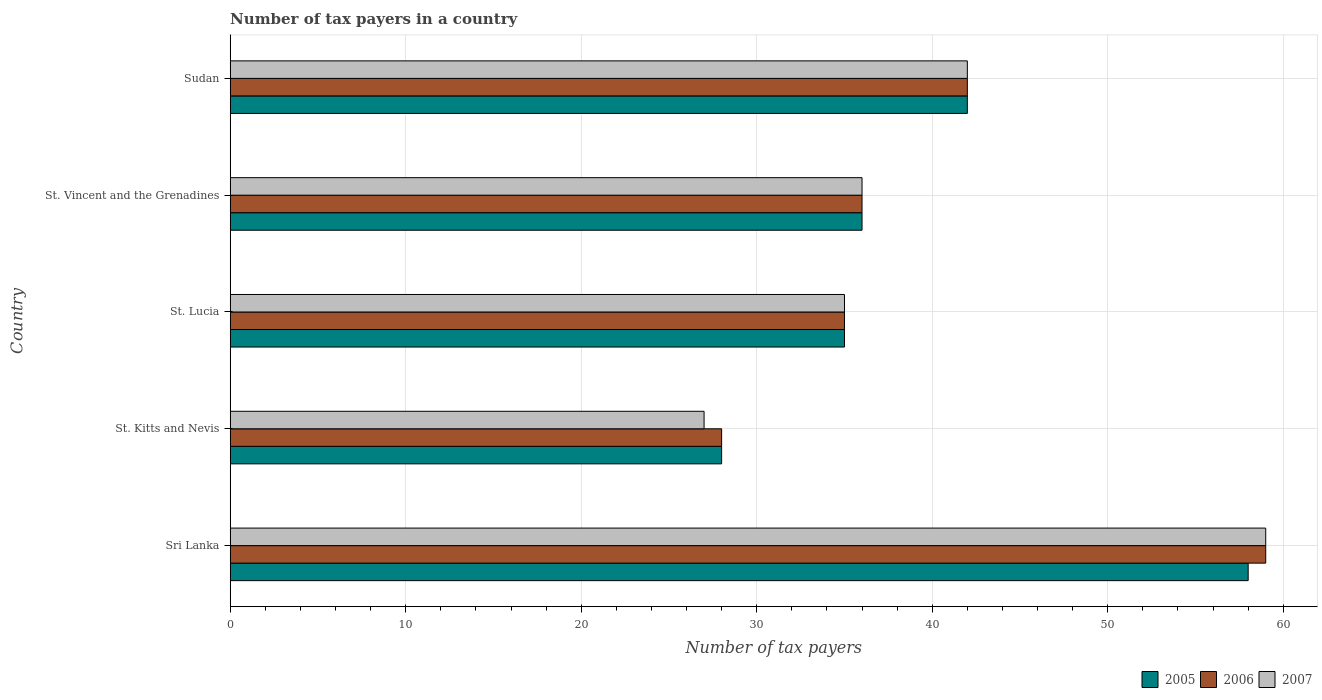How many different coloured bars are there?
Your answer should be very brief. 3. How many groups of bars are there?
Ensure brevity in your answer.  5. Are the number of bars per tick equal to the number of legend labels?
Offer a terse response. Yes. Are the number of bars on each tick of the Y-axis equal?
Offer a very short reply. Yes. How many bars are there on the 4th tick from the top?
Provide a succinct answer. 3. How many bars are there on the 3rd tick from the bottom?
Your answer should be very brief. 3. What is the label of the 1st group of bars from the top?
Your response must be concise. Sudan. In how many cases, is the number of bars for a given country not equal to the number of legend labels?
Your answer should be compact. 0. What is the number of tax payers in in 2006 in St. Lucia?
Make the answer very short. 35. Across all countries, what is the maximum number of tax payers in in 2005?
Make the answer very short. 58. Across all countries, what is the minimum number of tax payers in in 2006?
Keep it short and to the point. 28. In which country was the number of tax payers in in 2005 maximum?
Provide a short and direct response. Sri Lanka. In which country was the number of tax payers in in 2005 minimum?
Ensure brevity in your answer.  St. Kitts and Nevis. What is the total number of tax payers in in 2006 in the graph?
Your response must be concise. 200. What is the difference between the number of tax payers in in 2007 in St. Vincent and the Grenadines and that in Sudan?
Make the answer very short. -6. In how many countries, is the number of tax payers in in 2006 greater than 56 ?
Ensure brevity in your answer.  1. What is the ratio of the number of tax payers in in 2006 in Sri Lanka to that in St. Vincent and the Grenadines?
Make the answer very short. 1.64. What is the difference between the highest and the second highest number of tax payers in in 2005?
Keep it short and to the point. 16. What is the difference between the highest and the lowest number of tax payers in in 2007?
Your answer should be very brief. 32. In how many countries, is the number of tax payers in in 2005 greater than the average number of tax payers in in 2005 taken over all countries?
Offer a very short reply. 2. Is the sum of the number of tax payers in in 2006 in St. Vincent and the Grenadines and Sudan greater than the maximum number of tax payers in in 2005 across all countries?
Your response must be concise. Yes. How many bars are there?
Offer a terse response. 15. Are all the bars in the graph horizontal?
Provide a short and direct response. Yes. What is the difference between two consecutive major ticks on the X-axis?
Keep it short and to the point. 10. Are the values on the major ticks of X-axis written in scientific E-notation?
Offer a very short reply. No. Does the graph contain grids?
Your response must be concise. Yes. How are the legend labels stacked?
Give a very brief answer. Horizontal. What is the title of the graph?
Your response must be concise. Number of tax payers in a country. Does "1985" appear as one of the legend labels in the graph?
Your answer should be compact. No. What is the label or title of the X-axis?
Give a very brief answer. Number of tax payers. What is the label or title of the Y-axis?
Give a very brief answer. Country. What is the Number of tax payers in 2005 in Sri Lanka?
Your answer should be compact. 58. What is the Number of tax payers of 2006 in Sri Lanka?
Your answer should be compact. 59. What is the Number of tax payers in 2006 in St. Lucia?
Your response must be concise. 35. What is the Number of tax payers of 2007 in St. Lucia?
Offer a very short reply. 35. What is the Number of tax payers in 2006 in St. Vincent and the Grenadines?
Offer a terse response. 36. Across all countries, what is the maximum Number of tax payers in 2005?
Make the answer very short. 58. Across all countries, what is the maximum Number of tax payers in 2007?
Give a very brief answer. 59. Across all countries, what is the minimum Number of tax payers in 2005?
Your answer should be compact. 28. Across all countries, what is the minimum Number of tax payers of 2006?
Offer a very short reply. 28. What is the total Number of tax payers of 2005 in the graph?
Ensure brevity in your answer.  199. What is the total Number of tax payers of 2006 in the graph?
Keep it short and to the point. 200. What is the total Number of tax payers in 2007 in the graph?
Offer a terse response. 199. What is the difference between the Number of tax payers of 2005 in Sri Lanka and that in St. Kitts and Nevis?
Give a very brief answer. 30. What is the difference between the Number of tax payers in 2005 in Sri Lanka and that in St. Lucia?
Your answer should be compact. 23. What is the difference between the Number of tax payers of 2007 in Sri Lanka and that in St. Lucia?
Your answer should be compact. 24. What is the difference between the Number of tax payers in 2005 in Sri Lanka and that in St. Vincent and the Grenadines?
Ensure brevity in your answer.  22. What is the difference between the Number of tax payers of 2006 in Sri Lanka and that in St. Vincent and the Grenadines?
Offer a very short reply. 23. What is the difference between the Number of tax payers of 2007 in Sri Lanka and that in St. Vincent and the Grenadines?
Your answer should be very brief. 23. What is the difference between the Number of tax payers of 2005 in Sri Lanka and that in Sudan?
Provide a short and direct response. 16. What is the difference between the Number of tax payers in 2007 in Sri Lanka and that in Sudan?
Provide a short and direct response. 17. What is the difference between the Number of tax payers in 2005 in St. Kitts and Nevis and that in St. Lucia?
Give a very brief answer. -7. What is the difference between the Number of tax payers of 2006 in St. Kitts and Nevis and that in St. Lucia?
Provide a short and direct response. -7. What is the difference between the Number of tax payers of 2007 in St. Kitts and Nevis and that in St. Lucia?
Your response must be concise. -8. What is the difference between the Number of tax payers of 2005 in St. Kitts and Nevis and that in St. Vincent and the Grenadines?
Provide a succinct answer. -8. What is the difference between the Number of tax payers in 2006 in St. Kitts and Nevis and that in Sudan?
Your response must be concise. -14. What is the difference between the Number of tax payers of 2005 in St. Lucia and that in St. Vincent and the Grenadines?
Ensure brevity in your answer.  -1. What is the difference between the Number of tax payers in 2006 in St. Lucia and that in Sudan?
Your answer should be very brief. -7. What is the difference between the Number of tax payers of 2007 in St. Lucia and that in Sudan?
Offer a very short reply. -7. What is the difference between the Number of tax payers of 2005 in St. Vincent and the Grenadines and that in Sudan?
Your answer should be compact. -6. What is the difference between the Number of tax payers of 2005 in Sri Lanka and the Number of tax payers of 2007 in St. Kitts and Nevis?
Provide a short and direct response. 31. What is the difference between the Number of tax payers in 2006 in Sri Lanka and the Number of tax payers in 2007 in St. Lucia?
Provide a short and direct response. 24. What is the difference between the Number of tax payers in 2005 in Sri Lanka and the Number of tax payers in 2006 in St. Vincent and the Grenadines?
Give a very brief answer. 22. What is the difference between the Number of tax payers in 2005 in Sri Lanka and the Number of tax payers in 2007 in St. Vincent and the Grenadines?
Your answer should be compact. 22. What is the difference between the Number of tax payers in 2005 in Sri Lanka and the Number of tax payers in 2006 in Sudan?
Your response must be concise. 16. What is the difference between the Number of tax payers in 2005 in St. Kitts and Nevis and the Number of tax payers in 2006 in St. Vincent and the Grenadines?
Offer a terse response. -8. What is the difference between the Number of tax payers in 2005 in St. Kitts and Nevis and the Number of tax payers in 2007 in St. Vincent and the Grenadines?
Make the answer very short. -8. What is the difference between the Number of tax payers of 2005 in St. Kitts and Nevis and the Number of tax payers of 2006 in Sudan?
Your answer should be compact. -14. What is the difference between the Number of tax payers in 2005 in St. Lucia and the Number of tax payers in 2006 in St. Vincent and the Grenadines?
Your answer should be compact. -1. What is the difference between the Number of tax payers in 2006 in St. Lucia and the Number of tax payers in 2007 in St. Vincent and the Grenadines?
Provide a succinct answer. -1. What is the difference between the Number of tax payers in 2006 in St. Lucia and the Number of tax payers in 2007 in Sudan?
Keep it short and to the point. -7. What is the difference between the Number of tax payers in 2005 in St. Vincent and the Grenadines and the Number of tax payers in 2006 in Sudan?
Offer a very short reply. -6. What is the difference between the Number of tax payers of 2005 in St. Vincent and the Grenadines and the Number of tax payers of 2007 in Sudan?
Your answer should be very brief. -6. What is the average Number of tax payers of 2005 per country?
Provide a succinct answer. 39.8. What is the average Number of tax payers in 2007 per country?
Your answer should be very brief. 39.8. What is the difference between the Number of tax payers in 2005 and Number of tax payers in 2006 in Sri Lanka?
Offer a terse response. -1. What is the difference between the Number of tax payers in 2005 and Number of tax payers in 2007 in Sri Lanka?
Make the answer very short. -1. What is the difference between the Number of tax payers of 2006 and Number of tax payers of 2007 in Sri Lanka?
Your response must be concise. 0. What is the difference between the Number of tax payers in 2005 and Number of tax payers in 2006 in St. Vincent and the Grenadines?
Give a very brief answer. 0. What is the difference between the Number of tax payers in 2005 and Number of tax payers in 2006 in Sudan?
Offer a very short reply. 0. What is the ratio of the Number of tax payers in 2005 in Sri Lanka to that in St. Kitts and Nevis?
Provide a short and direct response. 2.07. What is the ratio of the Number of tax payers in 2006 in Sri Lanka to that in St. Kitts and Nevis?
Your answer should be very brief. 2.11. What is the ratio of the Number of tax payers in 2007 in Sri Lanka to that in St. Kitts and Nevis?
Offer a terse response. 2.19. What is the ratio of the Number of tax payers in 2005 in Sri Lanka to that in St. Lucia?
Ensure brevity in your answer.  1.66. What is the ratio of the Number of tax payers in 2006 in Sri Lanka to that in St. Lucia?
Your answer should be compact. 1.69. What is the ratio of the Number of tax payers of 2007 in Sri Lanka to that in St. Lucia?
Your response must be concise. 1.69. What is the ratio of the Number of tax payers of 2005 in Sri Lanka to that in St. Vincent and the Grenadines?
Offer a terse response. 1.61. What is the ratio of the Number of tax payers in 2006 in Sri Lanka to that in St. Vincent and the Grenadines?
Provide a short and direct response. 1.64. What is the ratio of the Number of tax payers of 2007 in Sri Lanka to that in St. Vincent and the Grenadines?
Your response must be concise. 1.64. What is the ratio of the Number of tax payers in 2005 in Sri Lanka to that in Sudan?
Ensure brevity in your answer.  1.38. What is the ratio of the Number of tax payers in 2006 in Sri Lanka to that in Sudan?
Offer a terse response. 1.4. What is the ratio of the Number of tax payers in 2007 in Sri Lanka to that in Sudan?
Give a very brief answer. 1.4. What is the ratio of the Number of tax payers of 2005 in St. Kitts and Nevis to that in St. Lucia?
Offer a terse response. 0.8. What is the ratio of the Number of tax payers of 2007 in St. Kitts and Nevis to that in St. Lucia?
Make the answer very short. 0.77. What is the ratio of the Number of tax payers of 2007 in St. Kitts and Nevis to that in St. Vincent and the Grenadines?
Offer a terse response. 0.75. What is the ratio of the Number of tax payers in 2005 in St. Kitts and Nevis to that in Sudan?
Give a very brief answer. 0.67. What is the ratio of the Number of tax payers in 2006 in St. Kitts and Nevis to that in Sudan?
Your answer should be compact. 0.67. What is the ratio of the Number of tax payers in 2007 in St. Kitts and Nevis to that in Sudan?
Make the answer very short. 0.64. What is the ratio of the Number of tax payers of 2005 in St. Lucia to that in St. Vincent and the Grenadines?
Offer a terse response. 0.97. What is the ratio of the Number of tax payers of 2006 in St. Lucia to that in St. Vincent and the Grenadines?
Your answer should be very brief. 0.97. What is the ratio of the Number of tax payers of 2007 in St. Lucia to that in St. Vincent and the Grenadines?
Your answer should be compact. 0.97. What is the ratio of the Number of tax payers in 2007 in St. Lucia to that in Sudan?
Offer a terse response. 0.83. What is the ratio of the Number of tax payers in 2006 in St. Vincent and the Grenadines to that in Sudan?
Provide a short and direct response. 0.86. What is the ratio of the Number of tax payers of 2007 in St. Vincent and the Grenadines to that in Sudan?
Your response must be concise. 0.86. What is the difference between the highest and the second highest Number of tax payers of 2006?
Provide a succinct answer. 17. What is the difference between the highest and the second highest Number of tax payers in 2007?
Your answer should be very brief. 17. What is the difference between the highest and the lowest Number of tax payers of 2005?
Ensure brevity in your answer.  30. What is the difference between the highest and the lowest Number of tax payers of 2006?
Offer a very short reply. 31. 